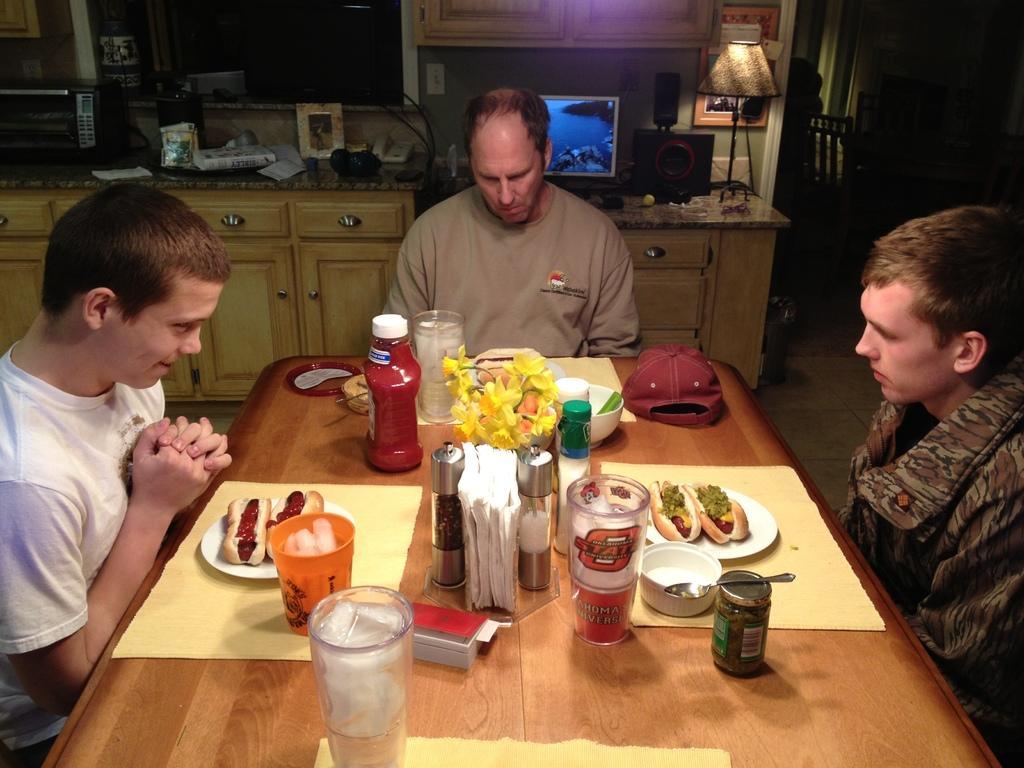Please provide a concise description of this image. In this image in the center there is a table and on the table there are glasses, tissues and there are plates and on the plates there is food, there is a cap which is red in colour and in the center there are persons sitting. In the background there is a monitor, there is a speaker, there is a light and there are objects which are white and cream in colour and on the left side there is an oven. On the right side there is a chair and there is a wardrobe on the wall and there is a window and there are cupboards. 